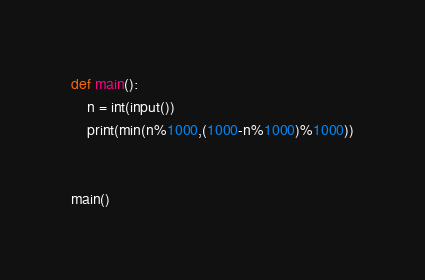Convert code to text. <code><loc_0><loc_0><loc_500><loc_500><_Python_>def main():
    n = int(input())
    print(min(n%1000,(1000-n%1000)%1000))
    

main()
</code> 